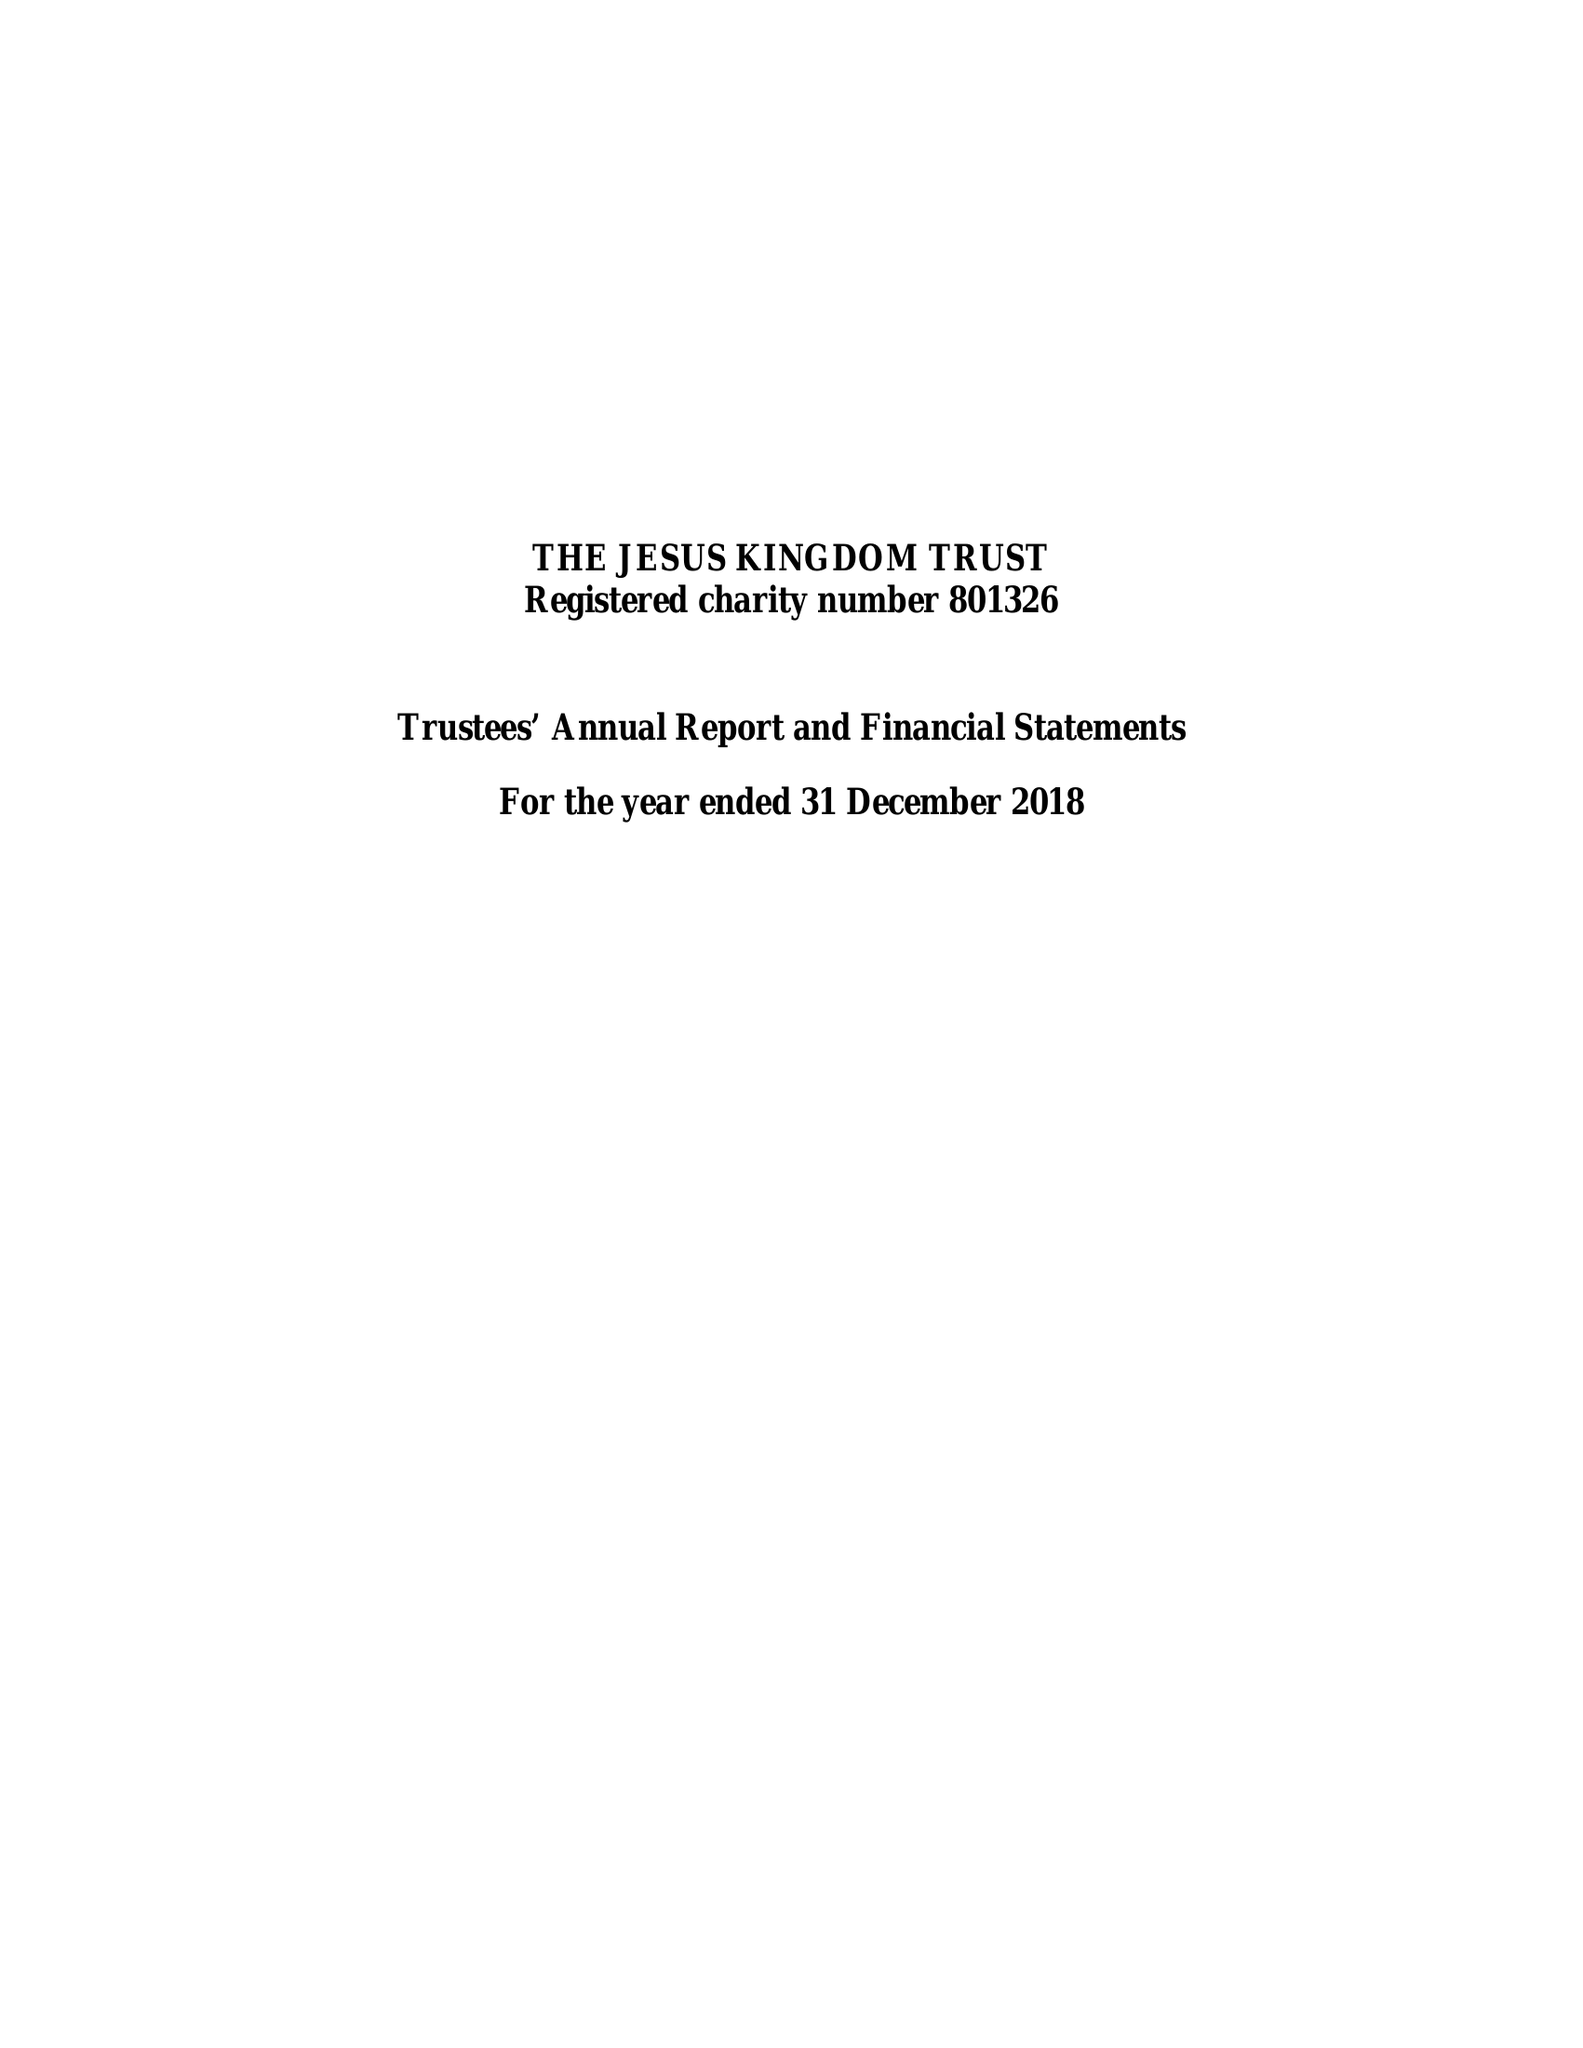What is the value for the income_annually_in_british_pounds?
Answer the question using a single word or phrase. 479844.00 